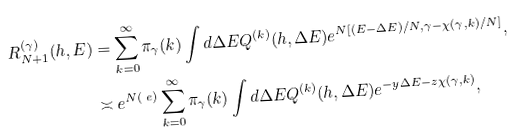<formula> <loc_0><loc_0><loc_500><loc_500>R ^ { ( \gamma ) } _ { N + 1 } ( h , E ) & = \sum _ { k = 0 } ^ { \infty } \pi _ { \gamma } ( k ) \int d \Delta E Q ^ { ( k ) } ( h , \Delta E ) e ^ { N \L [ ( E - \Delta E ) / N , \gamma - \chi ( \gamma , k ) / N ] } , \\ & \asymp e ^ { N \L ( \ e ) } \sum _ { k = 0 } ^ { \infty } \pi _ { \gamma } ( k ) \int d \Delta E Q ^ { ( k ) } ( h , \Delta E ) e ^ { - y \Delta E - z \chi ( \gamma , k ) } ,</formula> 